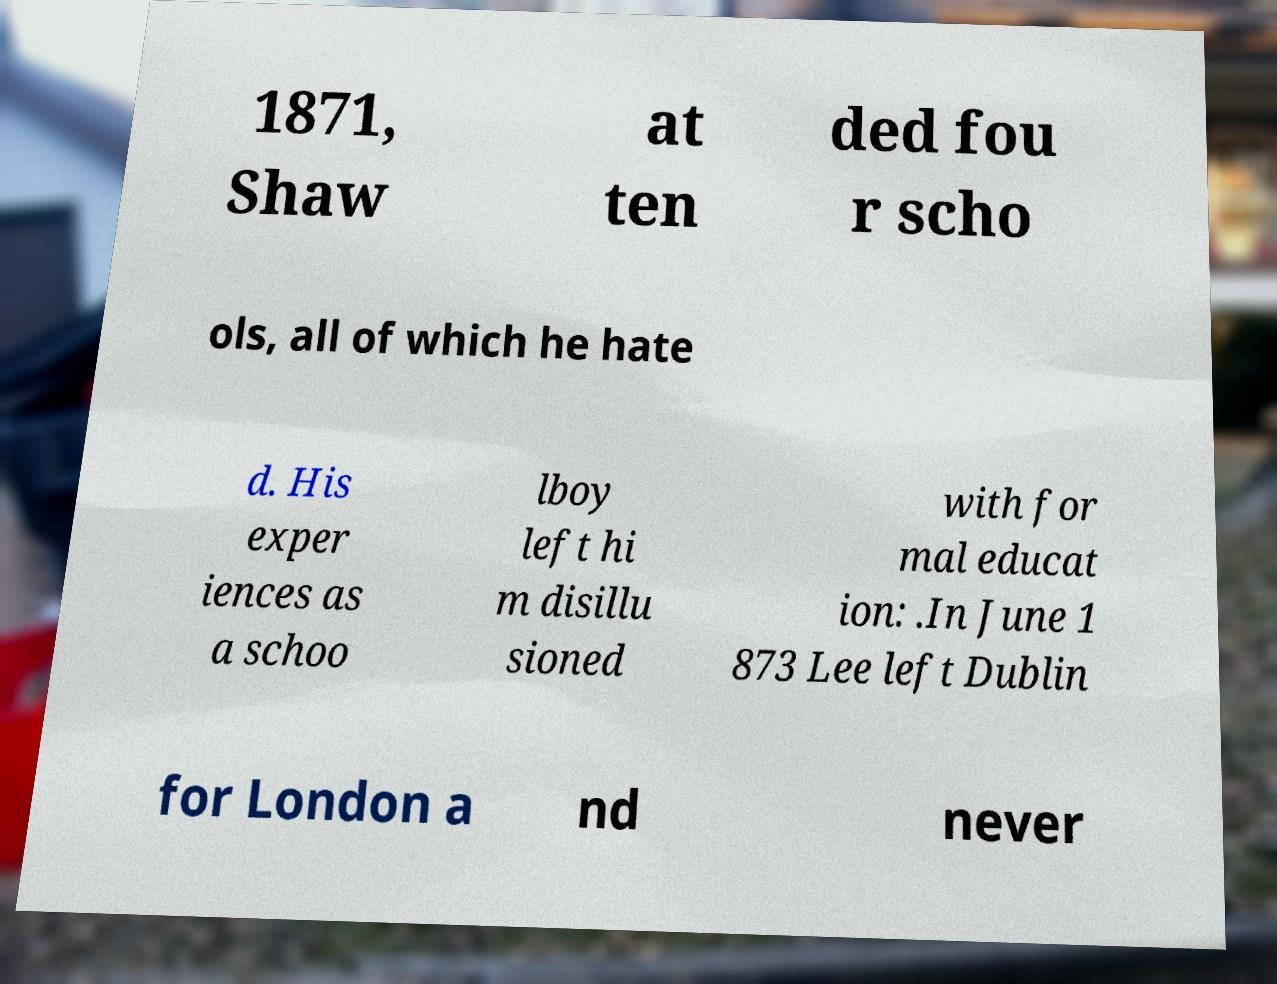What messages or text are displayed in this image? I need them in a readable, typed format. 1871, Shaw at ten ded fou r scho ols, all of which he hate d. His exper iences as a schoo lboy left hi m disillu sioned with for mal educat ion: .In June 1 873 Lee left Dublin for London a nd never 